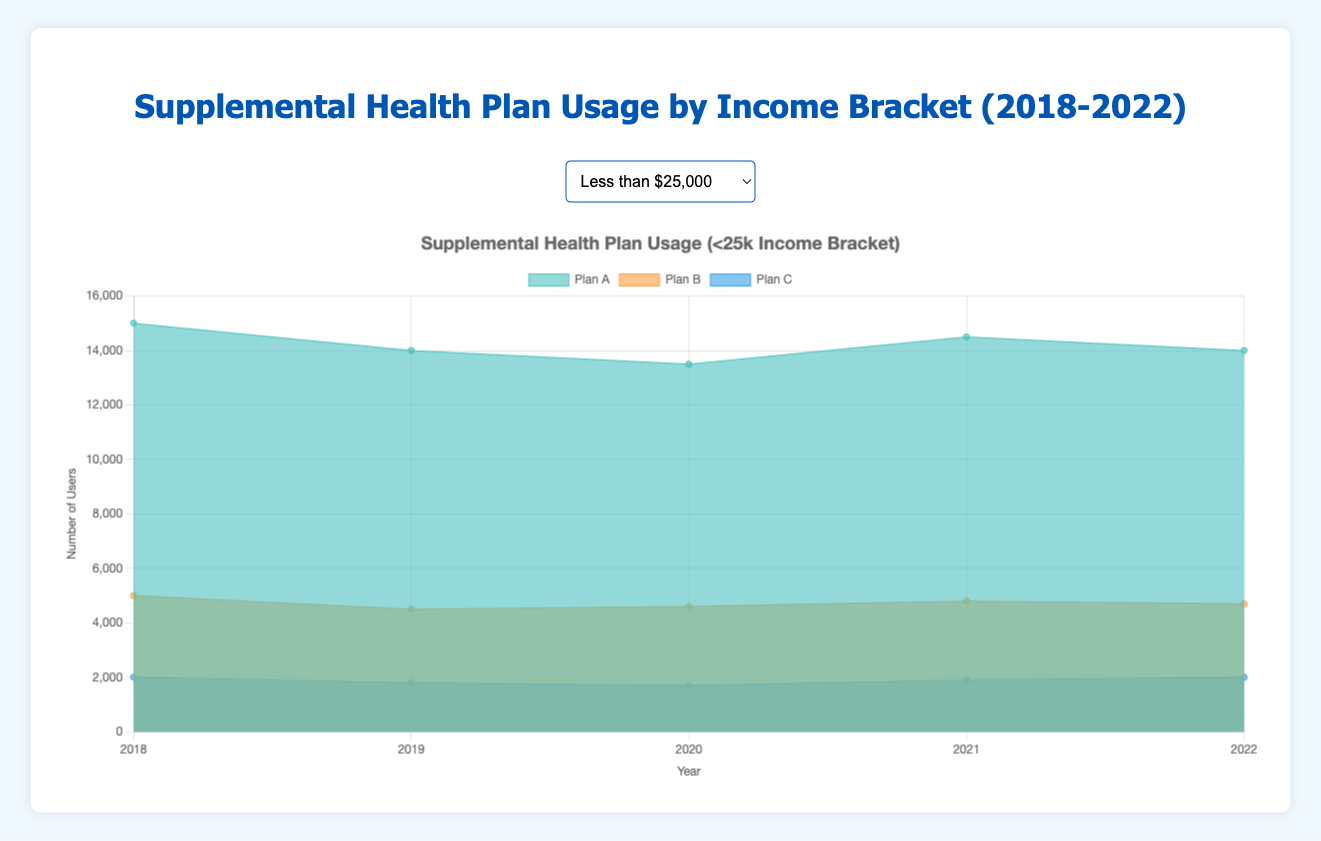What is the overall trend for Plan A usage in the income bracket < $25,000 from 2018 to 2022? The chart shows that Plan A usage starts at 15,000 in 2018, then decreases to 14,000 in 2019 and 13,500 in 2020, rises to 14,500 in 2021, and slightly falls back to 14,000 in 2022. This indicates a slight overall decreasing trend with a minor rebound in 2021.
Answer: Slightly Decreasing How does the usage of Plan C compare between the income brackets $25,000 - $50,000 and $50,000 - $100,000 in 2022? For the $25,000 - $50,000 bracket, Plan C usage in 2022 is 4,500. For the $50,000 - $100,000 bracket, Plan C usage in 2022 is 4,000. The usage for the $25,000 - $50,000 bracket is slightly higher.
Answer: $25,000 - $50,000 is higher What is the average number of users for Plan B in the income bracket $100,000 - $150,000 from 2018 to 2022? The values for Plan B are 4,000, 4,200, 4,500, 4,600, and 4,700. The sum is: 4,000 + 4,200 + 4,500 + 4,600 + 4,700 = 22,000. The average is: 22,000 / 5 = 4,400.
Answer: 4,400 Which plan had the highest number of users in the income bracket > $150,000 in 2020? In 2020, Plan A had 5,400 users, Plan B had 2,300 users, and Plan C had 1,200 users in the > $150,000 bracket. Plan A had the highest number of users.
Answer: Plan A Between which years did Plan B use increase the most in the income bracket less than $25,000? To find where the biggest increase happened, look at the difference between consecutive years for Plan B: 2018-2019 (5,000-4,500 = -500), 2019-2020 (4,500-4,600 = 100), 2020-2021 (4,600-4,800 = 200), 2021-2022 (4,800-4,700 = -100). The largest increase happens between 2020 and 2021.
Answer: 2020 and 2021 What is the total number of users of Plan C in the $50,000 - $100,000 income bracket over the five years? Summing up all the values for Plan C in the $50,000 - $100,000 bracket: 3,000 + 3,200 + 3,500 + 3,700 + 4,000 = 17,400.
Answer: 17,400 Which income bracket had the smallest increase in the number of users for Plan A from 2018 to 2022? Compare the increase in Plan A users from 2018 to 2022 in each income bracket: <25k (14,000 - 15,000 = -1,000), 25k-50k (27,000 - 25,000 = 2,000), 50k-100k (22,500 - 20,000 = 2,500), 100k-150k (12,000 - 10,000 = 2,000), >150k (5,600 - 5,000 = 600). The <25k bracket actually saw a decrease, and the smallest increase is from >150k.
Answer: >150k In which year did the Plan B user base in the $25,000 - $50,000 income bracket surpass 11,000 users? By checking each year for Plan B in the $25,000 - $50,000 bracket: 2018 (10,000), 2019 (10,500), 2020 (11,000), 2021 (11,500). The user base surpassed 11,000 in 2021.
Answer: 2021 